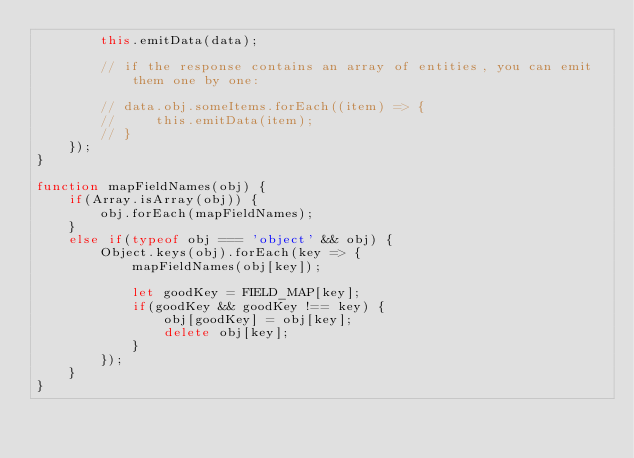Convert code to text. <code><loc_0><loc_0><loc_500><loc_500><_JavaScript_>        this.emitData(data);

        // if the response contains an array of entities, you can emit them one by one:

        // data.obj.someItems.forEach((item) => {
        //     this.emitData(item);
        // }
    });
}

function mapFieldNames(obj) {
    if(Array.isArray(obj)) {
        obj.forEach(mapFieldNames);
    }
    else if(typeof obj === 'object' && obj) {
        Object.keys(obj).forEach(key => {
            mapFieldNames(obj[key]);

            let goodKey = FIELD_MAP[key];
            if(goodKey && goodKey !== key) {
                obj[goodKey] = obj[key];
                delete obj[key];
            }
        });
    }
}</code> 